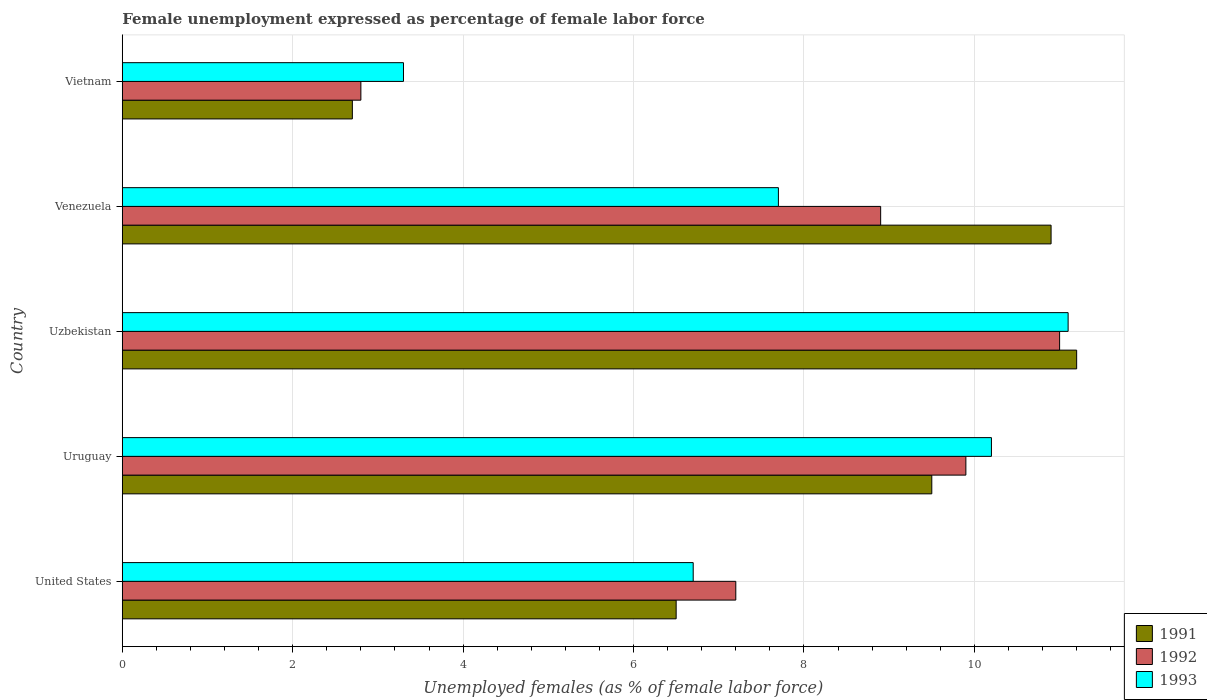How many different coloured bars are there?
Your answer should be very brief. 3. How many groups of bars are there?
Provide a short and direct response. 5. Are the number of bars per tick equal to the number of legend labels?
Offer a very short reply. Yes. How many bars are there on the 1st tick from the bottom?
Offer a terse response. 3. What is the label of the 4th group of bars from the top?
Your answer should be very brief. Uruguay. In how many cases, is the number of bars for a given country not equal to the number of legend labels?
Your answer should be compact. 0. What is the unemployment in females in in 1992 in Vietnam?
Make the answer very short. 2.8. Across all countries, what is the maximum unemployment in females in in 1993?
Offer a terse response. 11.1. Across all countries, what is the minimum unemployment in females in in 1992?
Your response must be concise. 2.8. In which country was the unemployment in females in in 1991 maximum?
Keep it short and to the point. Uzbekistan. In which country was the unemployment in females in in 1993 minimum?
Give a very brief answer. Vietnam. What is the total unemployment in females in in 1993 in the graph?
Keep it short and to the point. 39. What is the difference between the unemployment in females in in 1993 in Uzbekistan and that in Venezuela?
Provide a short and direct response. 3.4. What is the difference between the unemployment in females in in 1993 in Uzbekistan and the unemployment in females in in 1992 in Venezuela?
Provide a short and direct response. 2.2. What is the average unemployment in females in in 1991 per country?
Make the answer very short. 8.16. What is the difference between the unemployment in females in in 1992 and unemployment in females in in 1991 in Uruguay?
Offer a very short reply. 0.4. What is the ratio of the unemployment in females in in 1992 in Uruguay to that in Uzbekistan?
Provide a succinct answer. 0.9. Is the unemployment in females in in 1993 in United States less than that in Venezuela?
Your answer should be very brief. Yes. Is the difference between the unemployment in females in in 1992 in United States and Venezuela greater than the difference between the unemployment in females in in 1991 in United States and Venezuela?
Keep it short and to the point. Yes. What is the difference between the highest and the second highest unemployment in females in in 1993?
Ensure brevity in your answer.  0.9. What is the difference between the highest and the lowest unemployment in females in in 1991?
Provide a short and direct response. 8.5. What does the 2nd bar from the top in United States represents?
Provide a succinct answer. 1992. What does the 3rd bar from the bottom in Venezuela represents?
Your response must be concise. 1993. Are all the bars in the graph horizontal?
Offer a very short reply. Yes. How many countries are there in the graph?
Ensure brevity in your answer.  5. Does the graph contain grids?
Keep it short and to the point. Yes. How many legend labels are there?
Give a very brief answer. 3. What is the title of the graph?
Offer a terse response. Female unemployment expressed as percentage of female labor force. Does "1991" appear as one of the legend labels in the graph?
Give a very brief answer. Yes. What is the label or title of the X-axis?
Offer a terse response. Unemployed females (as % of female labor force). What is the Unemployed females (as % of female labor force) of 1992 in United States?
Ensure brevity in your answer.  7.2. What is the Unemployed females (as % of female labor force) of 1993 in United States?
Provide a succinct answer. 6.7. What is the Unemployed females (as % of female labor force) in 1992 in Uruguay?
Offer a very short reply. 9.9. What is the Unemployed females (as % of female labor force) in 1993 in Uruguay?
Make the answer very short. 10.2. What is the Unemployed females (as % of female labor force) in 1991 in Uzbekistan?
Give a very brief answer. 11.2. What is the Unemployed females (as % of female labor force) of 1993 in Uzbekistan?
Ensure brevity in your answer.  11.1. What is the Unemployed females (as % of female labor force) of 1991 in Venezuela?
Offer a terse response. 10.9. What is the Unemployed females (as % of female labor force) of 1992 in Venezuela?
Keep it short and to the point. 8.9. What is the Unemployed females (as % of female labor force) of 1993 in Venezuela?
Offer a terse response. 7.7. What is the Unemployed females (as % of female labor force) in 1991 in Vietnam?
Your answer should be compact. 2.7. What is the Unemployed females (as % of female labor force) of 1992 in Vietnam?
Offer a terse response. 2.8. What is the Unemployed females (as % of female labor force) in 1993 in Vietnam?
Provide a short and direct response. 3.3. Across all countries, what is the maximum Unemployed females (as % of female labor force) of 1991?
Give a very brief answer. 11.2. Across all countries, what is the maximum Unemployed females (as % of female labor force) in 1992?
Provide a succinct answer. 11. Across all countries, what is the maximum Unemployed females (as % of female labor force) in 1993?
Your answer should be compact. 11.1. Across all countries, what is the minimum Unemployed females (as % of female labor force) of 1991?
Offer a very short reply. 2.7. Across all countries, what is the minimum Unemployed females (as % of female labor force) of 1992?
Your answer should be compact. 2.8. Across all countries, what is the minimum Unemployed females (as % of female labor force) of 1993?
Your answer should be compact. 3.3. What is the total Unemployed females (as % of female labor force) of 1991 in the graph?
Your answer should be compact. 40.8. What is the total Unemployed females (as % of female labor force) of 1992 in the graph?
Ensure brevity in your answer.  39.8. What is the total Unemployed females (as % of female labor force) of 1993 in the graph?
Your response must be concise. 39. What is the difference between the Unemployed females (as % of female labor force) in 1991 in United States and that in Uruguay?
Provide a short and direct response. -3. What is the difference between the Unemployed females (as % of female labor force) of 1993 in United States and that in Uruguay?
Your answer should be compact. -3.5. What is the difference between the Unemployed females (as % of female labor force) in 1991 in United States and that in Uzbekistan?
Make the answer very short. -4.7. What is the difference between the Unemployed females (as % of female labor force) in 1993 in United States and that in Venezuela?
Ensure brevity in your answer.  -1. What is the difference between the Unemployed females (as % of female labor force) in 1991 in Uruguay and that in Uzbekistan?
Provide a short and direct response. -1.7. What is the difference between the Unemployed females (as % of female labor force) of 1993 in Uruguay and that in Venezuela?
Provide a succinct answer. 2.5. What is the difference between the Unemployed females (as % of female labor force) in 1992 in Uruguay and that in Vietnam?
Provide a succinct answer. 7.1. What is the difference between the Unemployed females (as % of female labor force) of 1993 in Uzbekistan and that in Venezuela?
Give a very brief answer. 3.4. What is the difference between the Unemployed females (as % of female labor force) in 1992 in Uzbekistan and that in Vietnam?
Provide a succinct answer. 8.2. What is the difference between the Unemployed females (as % of female labor force) in 1991 in Venezuela and that in Vietnam?
Offer a very short reply. 8.2. What is the difference between the Unemployed females (as % of female labor force) in 1992 in Venezuela and that in Vietnam?
Provide a short and direct response. 6.1. What is the difference between the Unemployed females (as % of female labor force) of 1991 in United States and the Unemployed females (as % of female labor force) of 1992 in Uruguay?
Give a very brief answer. -3.4. What is the difference between the Unemployed females (as % of female labor force) in 1992 in United States and the Unemployed females (as % of female labor force) in 1993 in Uzbekistan?
Keep it short and to the point. -3.9. What is the difference between the Unemployed females (as % of female labor force) of 1991 in United States and the Unemployed females (as % of female labor force) of 1993 in Venezuela?
Offer a very short reply. -1.2. What is the difference between the Unemployed females (as % of female labor force) of 1991 in United States and the Unemployed females (as % of female labor force) of 1992 in Vietnam?
Your response must be concise. 3.7. What is the difference between the Unemployed females (as % of female labor force) in 1992 in United States and the Unemployed females (as % of female labor force) in 1993 in Vietnam?
Keep it short and to the point. 3.9. What is the difference between the Unemployed females (as % of female labor force) of 1991 in Uruguay and the Unemployed females (as % of female labor force) of 1992 in Uzbekistan?
Provide a succinct answer. -1.5. What is the difference between the Unemployed females (as % of female labor force) of 1992 in Uruguay and the Unemployed females (as % of female labor force) of 1993 in Uzbekistan?
Offer a terse response. -1.2. What is the difference between the Unemployed females (as % of female labor force) of 1991 in Uruguay and the Unemployed females (as % of female labor force) of 1993 in Venezuela?
Offer a very short reply. 1.8. What is the difference between the Unemployed females (as % of female labor force) in 1992 in Uruguay and the Unemployed females (as % of female labor force) in 1993 in Venezuela?
Your response must be concise. 2.2. What is the difference between the Unemployed females (as % of female labor force) in 1991 in Uruguay and the Unemployed females (as % of female labor force) in 1992 in Vietnam?
Provide a short and direct response. 6.7. What is the difference between the Unemployed females (as % of female labor force) of 1991 in Uruguay and the Unemployed females (as % of female labor force) of 1993 in Vietnam?
Keep it short and to the point. 6.2. What is the difference between the Unemployed females (as % of female labor force) in 1992 in Uruguay and the Unemployed females (as % of female labor force) in 1993 in Vietnam?
Your answer should be very brief. 6.6. What is the difference between the Unemployed females (as % of female labor force) in 1991 in Uzbekistan and the Unemployed females (as % of female labor force) in 1993 in Venezuela?
Your response must be concise. 3.5. What is the difference between the Unemployed females (as % of female labor force) of 1991 in Uzbekistan and the Unemployed females (as % of female labor force) of 1992 in Vietnam?
Ensure brevity in your answer.  8.4. What is the difference between the Unemployed females (as % of female labor force) of 1991 in Venezuela and the Unemployed females (as % of female labor force) of 1992 in Vietnam?
Provide a short and direct response. 8.1. What is the difference between the Unemployed females (as % of female labor force) of 1991 in Venezuela and the Unemployed females (as % of female labor force) of 1993 in Vietnam?
Your response must be concise. 7.6. What is the difference between the Unemployed females (as % of female labor force) in 1992 in Venezuela and the Unemployed females (as % of female labor force) in 1993 in Vietnam?
Provide a succinct answer. 5.6. What is the average Unemployed females (as % of female labor force) in 1991 per country?
Provide a short and direct response. 8.16. What is the average Unemployed females (as % of female labor force) of 1992 per country?
Offer a terse response. 7.96. What is the difference between the Unemployed females (as % of female labor force) in 1991 and Unemployed females (as % of female labor force) in 1992 in United States?
Offer a very short reply. -0.7. What is the difference between the Unemployed females (as % of female labor force) of 1991 and Unemployed females (as % of female labor force) of 1993 in United States?
Ensure brevity in your answer.  -0.2. What is the difference between the Unemployed females (as % of female labor force) in 1991 and Unemployed females (as % of female labor force) in 1993 in Uruguay?
Keep it short and to the point. -0.7. What is the difference between the Unemployed females (as % of female labor force) of 1992 and Unemployed females (as % of female labor force) of 1993 in Uruguay?
Make the answer very short. -0.3. What is the difference between the Unemployed females (as % of female labor force) of 1991 and Unemployed females (as % of female labor force) of 1992 in Uzbekistan?
Provide a short and direct response. 0.2. What is the difference between the Unemployed females (as % of female labor force) of 1991 and Unemployed females (as % of female labor force) of 1993 in Venezuela?
Your answer should be very brief. 3.2. What is the difference between the Unemployed females (as % of female labor force) of 1992 and Unemployed females (as % of female labor force) of 1993 in Venezuela?
Give a very brief answer. 1.2. What is the difference between the Unemployed females (as % of female labor force) of 1991 and Unemployed females (as % of female labor force) of 1992 in Vietnam?
Provide a short and direct response. -0.1. What is the difference between the Unemployed females (as % of female labor force) in 1991 and Unemployed females (as % of female labor force) in 1993 in Vietnam?
Give a very brief answer. -0.6. What is the difference between the Unemployed females (as % of female labor force) in 1992 and Unemployed females (as % of female labor force) in 1993 in Vietnam?
Your answer should be very brief. -0.5. What is the ratio of the Unemployed females (as % of female labor force) in 1991 in United States to that in Uruguay?
Ensure brevity in your answer.  0.68. What is the ratio of the Unemployed females (as % of female labor force) of 1992 in United States to that in Uruguay?
Your answer should be very brief. 0.73. What is the ratio of the Unemployed females (as % of female labor force) in 1993 in United States to that in Uruguay?
Give a very brief answer. 0.66. What is the ratio of the Unemployed females (as % of female labor force) in 1991 in United States to that in Uzbekistan?
Your answer should be compact. 0.58. What is the ratio of the Unemployed females (as % of female labor force) in 1992 in United States to that in Uzbekistan?
Ensure brevity in your answer.  0.65. What is the ratio of the Unemployed females (as % of female labor force) in 1993 in United States to that in Uzbekistan?
Your answer should be compact. 0.6. What is the ratio of the Unemployed females (as % of female labor force) of 1991 in United States to that in Venezuela?
Provide a short and direct response. 0.6. What is the ratio of the Unemployed females (as % of female labor force) in 1992 in United States to that in Venezuela?
Your response must be concise. 0.81. What is the ratio of the Unemployed females (as % of female labor force) in 1993 in United States to that in Venezuela?
Offer a terse response. 0.87. What is the ratio of the Unemployed females (as % of female labor force) in 1991 in United States to that in Vietnam?
Offer a terse response. 2.41. What is the ratio of the Unemployed females (as % of female labor force) of 1992 in United States to that in Vietnam?
Give a very brief answer. 2.57. What is the ratio of the Unemployed females (as % of female labor force) in 1993 in United States to that in Vietnam?
Ensure brevity in your answer.  2.03. What is the ratio of the Unemployed females (as % of female labor force) of 1991 in Uruguay to that in Uzbekistan?
Provide a succinct answer. 0.85. What is the ratio of the Unemployed females (as % of female labor force) of 1992 in Uruguay to that in Uzbekistan?
Make the answer very short. 0.9. What is the ratio of the Unemployed females (as % of female labor force) in 1993 in Uruguay to that in Uzbekistan?
Keep it short and to the point. 0.92. What is the ratio of the Unemployed females (as % of female labor force) in 1991 in Uruguay to that in Venezuela?
Offer a very short reply. 0.87. What is the ratio of the Unemployed females (as % of female labor force) in 1992 in Uruguay to that in Venezuela?
Give a very brief answer. 1.11. What is the ratio of the Unemployed females (as % of female labor force) in 1993 in Uruguay to that in Venezuela?
Offer a terse response. 1.32. What is the ratio of the Unemployed females (as % of female labor force) of 1991 in Uruguay to that in Vietnam?
Make the answer very short. 3.52. What is the ratio of the Unemployed females (as % of female labor force) in 1992 in Uruguay to that in Vietnam?
Provide a short and direct response. 3.54. What is the ratio of the Unemployed females (as % of female labor force) of 1993 in Uruguay to that in Vietnam?
Provide a short and direct response. 3.09. What is the ratio of the Unemployed females (as % of female labor force) of 1991 in Uzbekistan to that in Venezuela?
Provide a succinct answer. 1.03. What is the ratio of the Unemployed females (as % of female labor force) in 1992 in Uzbekistan to that in Venezuela?
Offer a terse response. 1.24. What is the ratio of the Unemployed females (as % of female labor force) of 1993 in Uzbekistan to that in Venezuela?
Provide a succinct answer. 1.44. What is the ratio of the Unemployed females (as % of female labor force) of 1991 in Uzbekistan to that in Vietnam?
Offer a very short reply. 4.15. What is the ratio of the Unemployed females (as % of female labor force) in 1992 in Uzbekistan to that in Vietnam?
Your answer should be very brief. 3.93. What is the ratio of the Unemployed females (as % of female labor force) of 1993 in Uzbekistan to that in Vietnam?
Your response must be concise. 3.36. What is the ratio of the Unemployed females (as % of female labor force) of 1991 in Venezuela to that in Vietnam?
Offer a very short reply. 4.04. What is the ratio of the Unemployed females (as % of female labor force) in 1992 in Venezuela to that in Vietnam?
Your response must be concise. 3.18. What is the ratio of the Unemployed females (as % of female labor force) of 1993 in Venezuela to that in Vietnam?
Your answer should be compact. 2.33. What is the difference between the highest and the second highest Unemployed females (as % of female labor force) in 1991?
Your response must be concise. 0.3. What is the difference between the highest and the second highest Unemployed females (as % of female labor force) of 1992?
Offer a terse response. 1.1. What is the difference between the highest and the lowest Unemployed females (as % of female labor force) in 1991?
Offer a terse response. 8.5. What is the difference between the highest and the lowest Unemployed females (as % of female labor force) in 1993?
Keep it short and to the point. 7.8. 